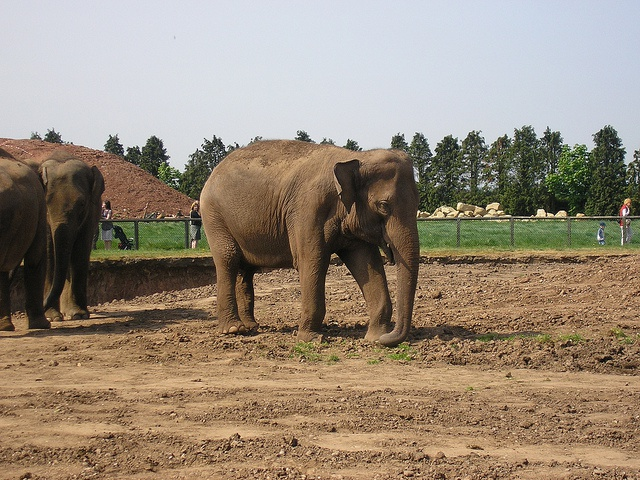Describe the objects in this image and their specific colors. I can see elephant in lavender, black, gray, maroon, and tan tones, elephant in lavender, black, maroon, and gray tones, elephant in lavender, black, gray, and maroon tones, people in lavender, black, gray, and maroon tones, and people in lavender, gray, black, and maroon tones in this image. 